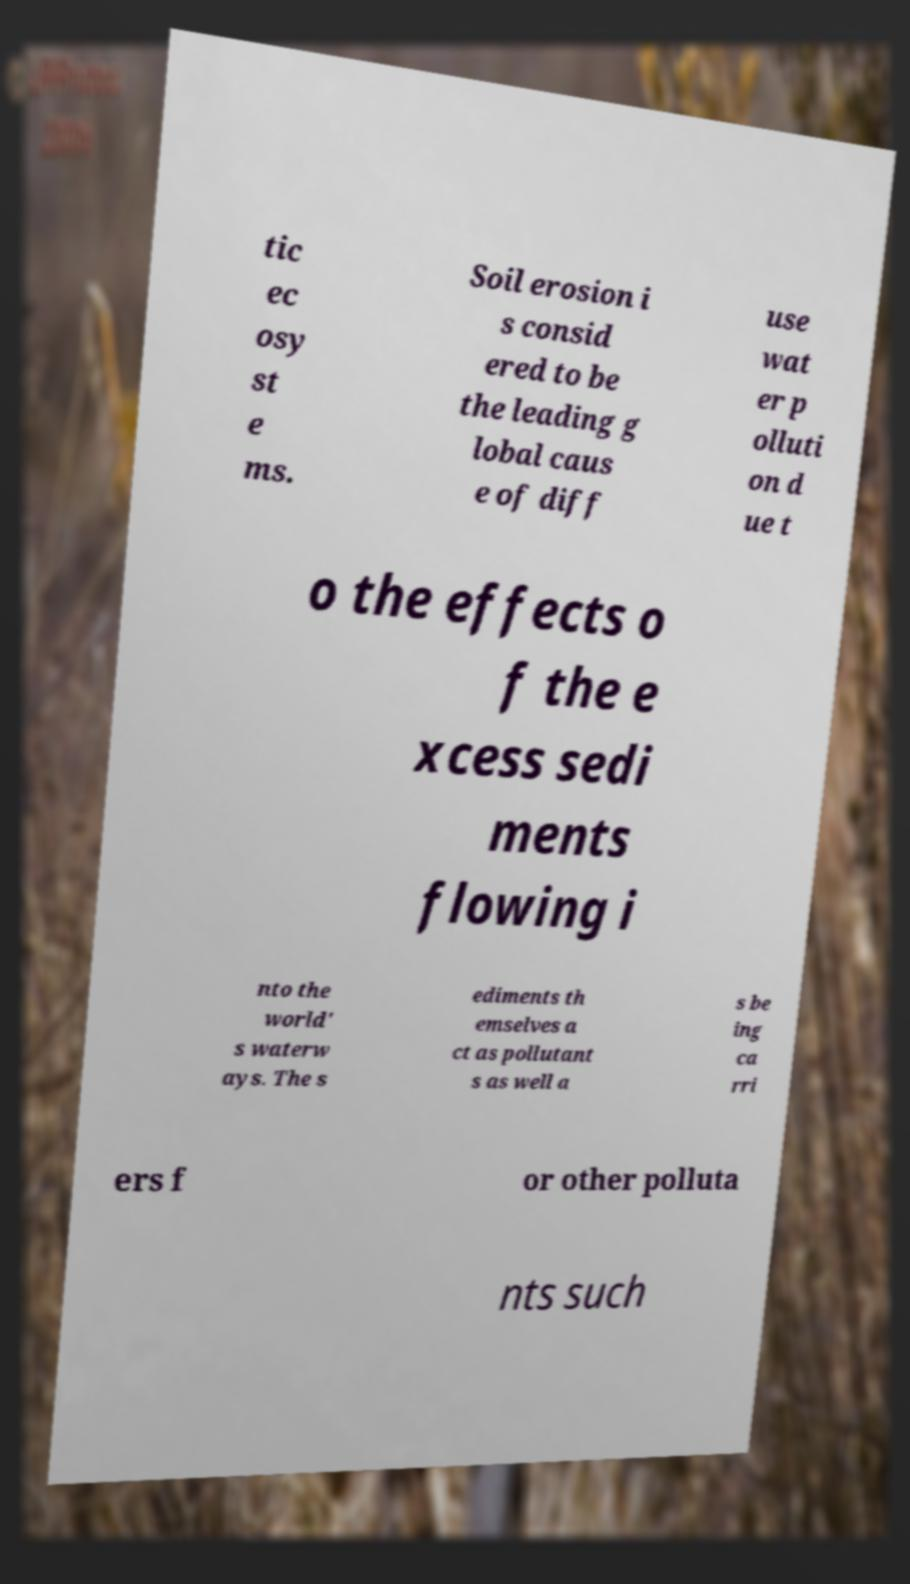Can you read and provide the text displayed in the image?This photo seems to have some interesting text. Can you extract and type it out for me? tic ec osy st e ms. Soil erosion i s consid ered to be the leading g lobal caus e of diff use wat er p olluti on d ue t o the effects o f the e xcess sedi ments flowing i nto the world' s waterw ays. The s ediments th emselves a ct as pollutant s as well a s be ing ca rri ers f or other polluta nts such 